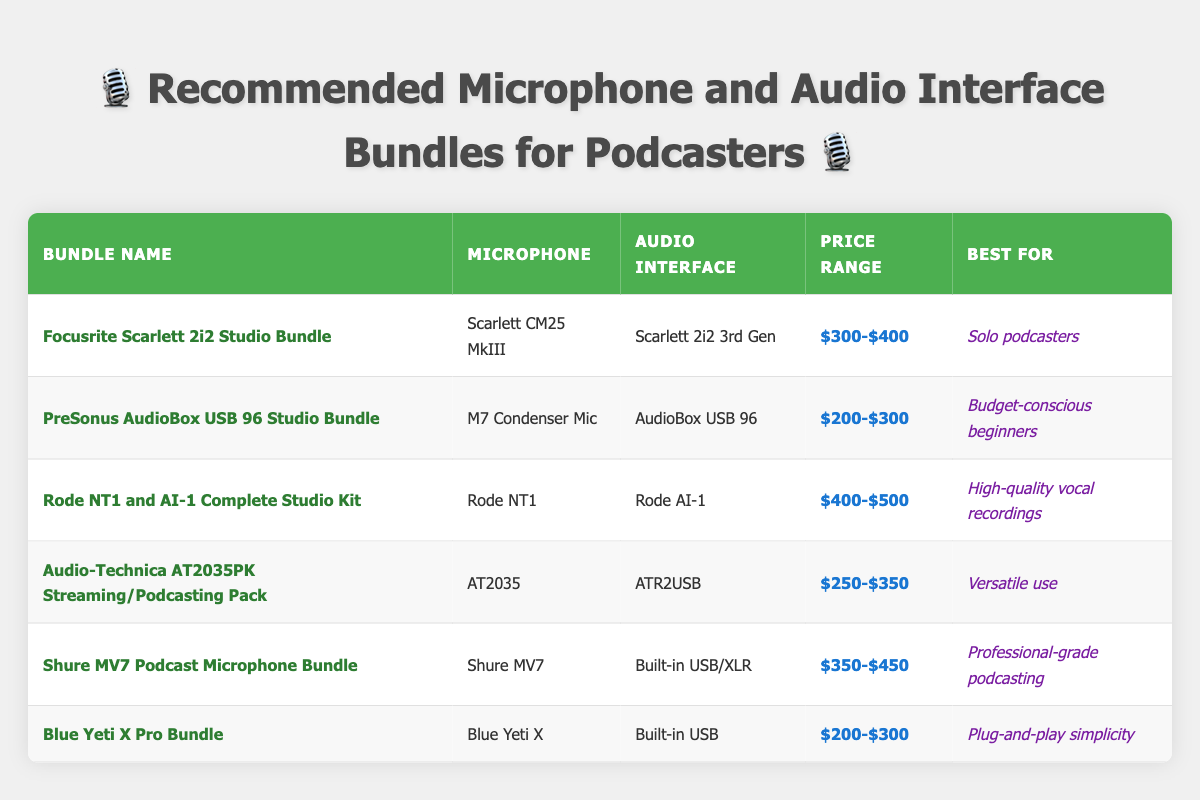What is the price range of the Rode NT1 and AI-1 Complete Studio Kit? The price range is listed in the table under the "Price Range" column for the corresponding bundle name "Rode NT1 and AI-1 Complete Studio Kit." It shows $400-$500.
Answer: $400-$500 Which bundle is best for budget-conscious beginners? The table provides a "Best For" column, and for the "PreSonus AudioBox USB 96 Studio Bundle," it states that it is best for budget-conscious beginners.
Answer: PreSonus AudioBox USB 96 Studio Bundle Are there any bundles that are suited for solo podcasters? By looking at the "Best For" column, we can see that the "Focusrite Scarlett 2i2 Studio Bundle" is specifically noted for solo podcasters, so the answer is yes.
Answer: Yes What is the average price range for all the bundles listed? To determine the average price, we take the mid-point of each price range: (350 + 250 + 450 + 300 + 400 + 250) / 6 = 300. Thus, the average price range is approximately $300.
Answer: $300 Is there a bundle that includes a built-in USB audio interface for a price under $300? The "Blue Yeti X Pro Bundle" is listed with a built-in USB interface and has a price range of $200-$300, thus answering yes to this question.
Answer: Yes How many bundles are best for professional-grade podcasting? By checking the "Best For" column, we see that only the "Shure MV7 Podcast Microphone Bundle" is categorized for professional-grade podcasting, indicating there is only one such bundle.
Answer: 1 Which bundle is recommended for versatile use? From the "Best For" column, the bundle listed for versatile use is the "Audio-Technica AT2035PK Streaming/Podcasting Pack."
Answer: Audio-Technica AT2035PK Streaming/Podcasting Pack Are all the bundles priced above $200? By reviewing the price ranges of all bundles, we can see that they range from $200-$300 for the Blue Yeti X Pro Bundle and the PreSonus option, which confirms that all bundles fall within this range. Therefore, the answer is yes.
Answer: Yes What is the total number of bundles suitable for high-quality vocal recordings? The "Rode NT1 and AI-1 Complete Studio Kit" is the only bundle listed for high-quality vocal recordings, making the total count one.
Answer: 1 